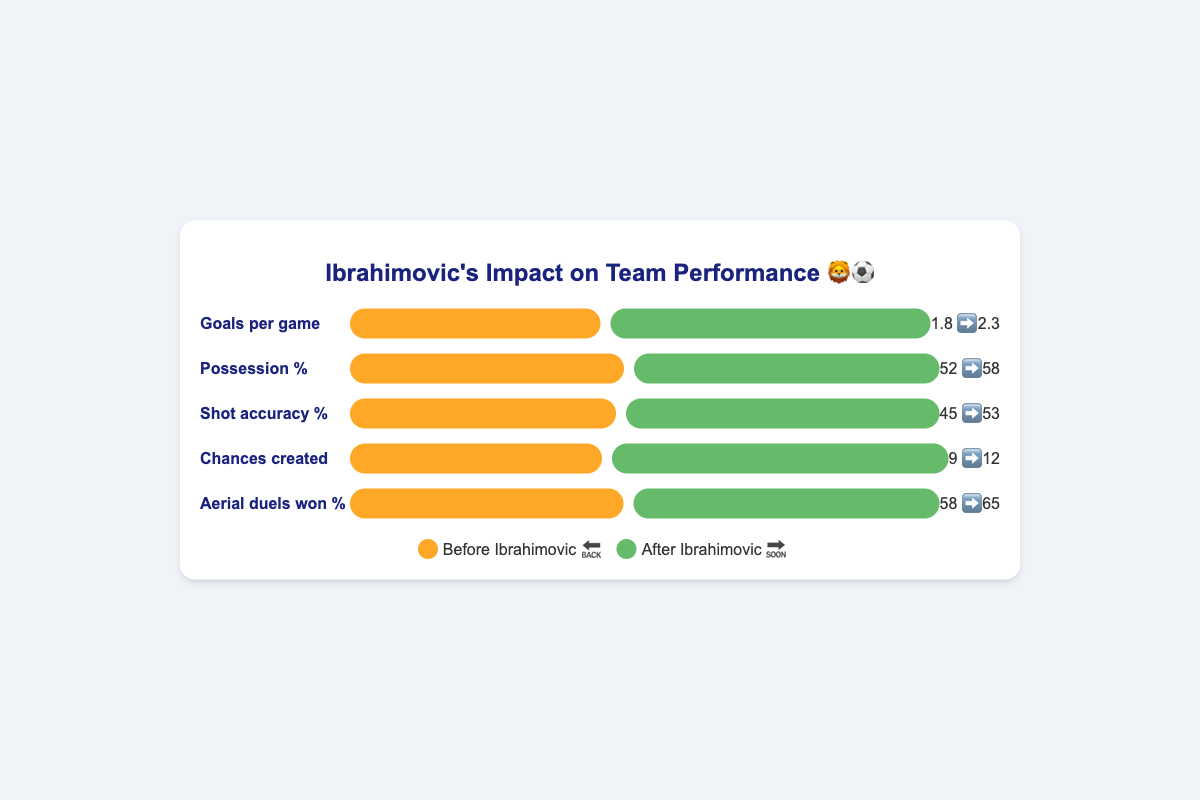What is the title of the figure? The title is found at the top of the figure and is typically the most prominent text element, indicated with a larger font size and often with color differentiation.
Answer: Ibrahimovic's Impact on Team Performance 🦁⚽ What metric shows the highest percentage change after Ibrahimovic joined the team? To find the highest percentage change, calculate the difference before and after for each metric, then identify which has the greatest value. Comparing changes: Goals per game = 0.5, Possession % = 6, Shot accuracy % = 8, Chances created = 3, Aerial duels won % = 7. The largest change is in Shot accuracy %.
Answer: Shot accuracy % How did the percentage of Aerial duels won change after Ibrahimovic joined? Refer to the "Aerial duels won %" metric in the chart, comparing the before value (58%) and after value (65%).
Answer: Increased by 7% What was the team's possession percentage before and after Ibrahimovic joined? Look at the "Possession %" metric in the chart, noting the values before (52) and after (58).
Answer: 52% before, 58% after By how much did the team's goals per game increase after Ibrahimovic joined? To find the increase, subtract the before value (1.8) from the after value (2.3).
Answer: 0.5 Compare the changes in shot accuracy % and chances created after Ibrahimovic joined. Which one improved more? Calculate the improvement for each: Shot accuracy % = 53 - 45 = 8, Chances created = 12 - 9 = 3. Shot accuracy improved more.
Answer: Shot accuracy % What is the difference in shot accuracy percentage before and after Ibrahimovic joined? Review the "Shot accuracy %" metric, then subtract the before value (45) from the after value (53).
Answer: 8% Which metric had the smallest change after Ibrahimovic joined the team? Calculate the difference for each metric: Goals per game = 0.5, Possession % = 6, Shot accuracy % = 8, Chances created = 3, and Aerial duels won % = 7. The smallest change is in "Goals per game".
Answer: Goals per game List all metrics that showed an improvement after Ibrahimovic joined the team. Check each metric's before and after values to see if the after value is greater than the before value. All metrics show improvement: Goals per game, Possession %, Shot accuracy %, Chances created, Aerial duels won %.
Answer: All metrics What is the range of percentage change in possession before and after Ibrahimovic joined? Find the difference between the minimum and maximum percentages for possession: 58 - 52.
Answer: 6 